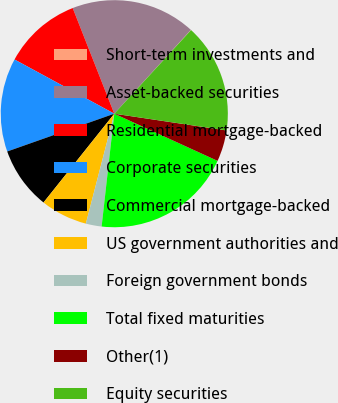Convert chart to OTSL. <chart><loc_0><loc_0><loc_500><loc_500><pie_chart><fcel>Short-term investments and<fcel>Asset-backed securities<fcel>Residential mortgage-backed<fcel>Corporate securities<fcel>Commercial mortgage-backed<fcel>US government authorities and<fcel>Foreign government bonds<fcel>Total fixed maturities<fcel>Other(1)<fcel>Equity securities<nl><fcel>0.04%<fcel>17.75%<fcel>11.11%<fcel>13.32%<fcel>8.89%<fcel>6.68%<fcel>2.25%<fcel>19.96%<fcel>4.46%<fcel>15.54%<nl></chart> 